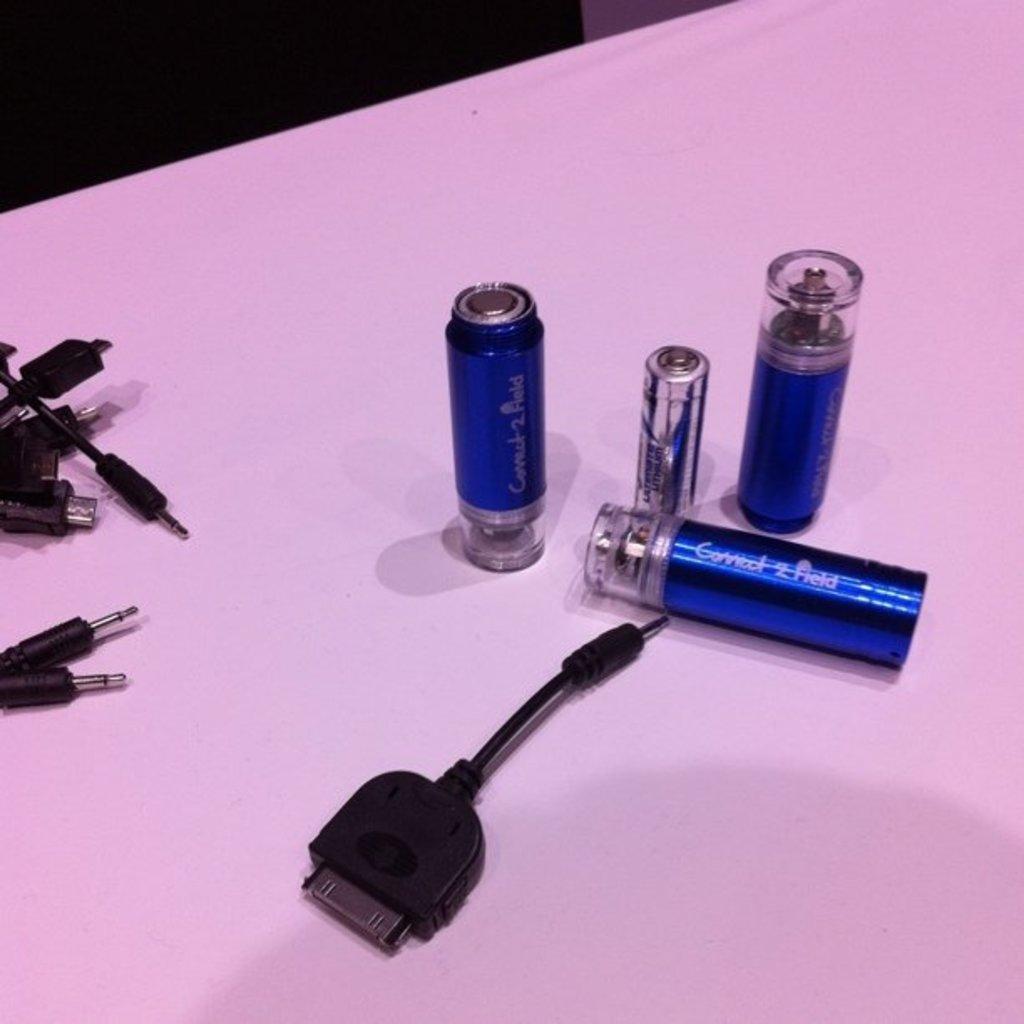Do the objects need to be connected?
Give a very brief answer. Answering does not require reading text in the image. What is the first word on the blue thing?
Offer a terse response. Connect. 